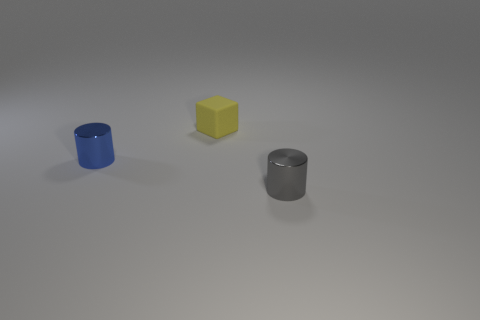The tiny matte block is what color? The tiny matte block in the image is a vibrant shade of yellow, reminiscent of the color of sunflowers or a canary. 